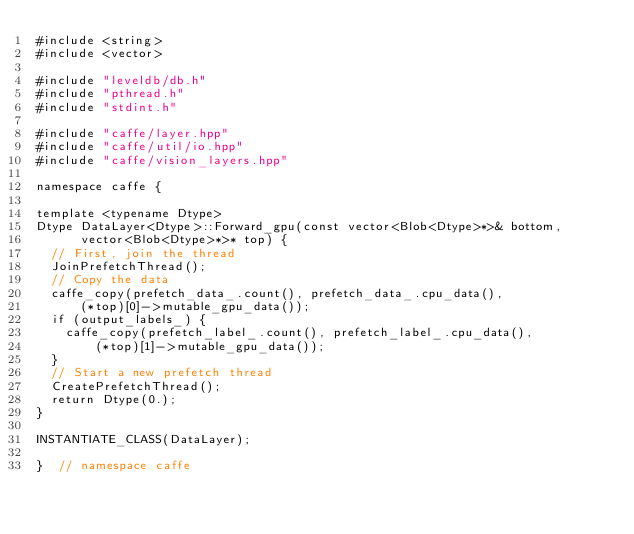<code> <loc_0><loc_0><loc_500><loc_500><_Cuda_>#include <string>
#include <vector>

#include "leveldb/db.h"
#include "pthread.h"
#include "stdint.h"

#include "caffe/layer.hpp"
#include "caffe/util/io.hpp"
#include "caffe/vision_layers.hpp"

namespace caffe {

template <typename Dtype>
Dtype DataLayer<Dtype>::Forward_gpu(const vector<Blob<Dtype>*>& bottom,
      vector<Blob<Dtype>*>* top) {
  // First, join the thread
  JoinPrefetchThread();
  // Copy the data
  caffe_copy(prefetch_data_.count(), prefetch_data_.cpu_data(),
      (*top)[0]->mutable_gpu_data());
  if (output_labels_) {
    caffe_copy(prefetch_label_.count(), prefetch_label_.cpu_data(),
        (*top)[1]->mutable_gpu_data());
  }
  // Start a new prefetch thread
  CreatePrefetchThread();
  return Dtype(0.);
}

INSTANTIATE_CLASS(DataLayer);

}  // namespace caffe
</code> 